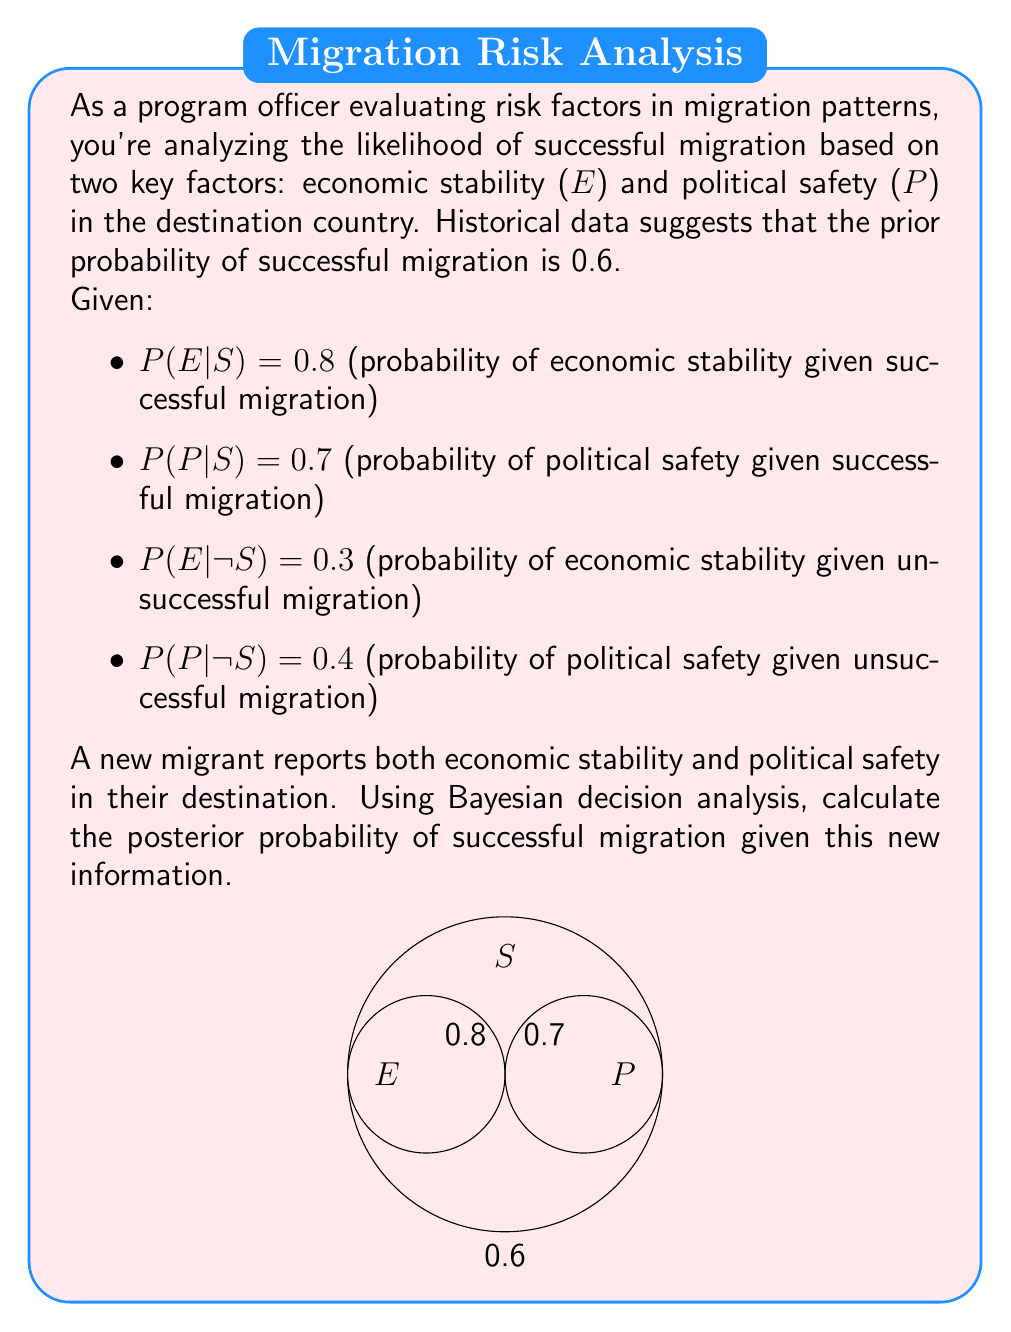Help me with this question. Let's approach this step-by-step using Bayes' theorem:

1) We want to calculate P(S|E,P), where S is successful migration, E is economic stability, and P is political safety.

2) Bayes' theorem states:

   $$P(S|E,P) = \frac{P(E,P|S) \cdot P(S)}{P(E,P)}$$

3) We're given P(S) = 0.6

4) To calculate P(E,P|S), we assume E and P are independent given S:
   
   $$P(E,P|S) = P(E|S) \cdot P(P|S) = 0.8 \cdot 0.7 = 0.56$$

5) To calculate P(E,P), we use the law of total probability:

   $$P(E,P) = P(E,P|S) \cdot P(S) + P(E,P|¬S) \cdot P(¬S)$$

6) We know P(S) = 0.6, so P(¬S) = 0.4

7) P(E,P|¬S) = P(E|¬S) · P(P|¬S) = 0.3 · 0.4 = 0.12

8) Now we can calculate P(E,P):

   $$P(E,P) = 0.56 \cdot 0.6 + 0.12 \cdot 0.4 = 0.336 + 0.048 = 0.384$$

9) Putting it all together in Bayes' theorem:

   $$P(S|E,P) = \frac{0.56 \cdot 0.6}{0.384} = \frac{0.336}{0.384} = 0.875$$

Therefore, the posterior probability of successful migration given both economic stability and political safety is 0.875 or 87.5%.
Answer: 0.875 